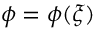Convert formula to latex. <formula><loc_0><loc_0><loc_500><loc_500>\phi = \phi ( \xi )</formula> 